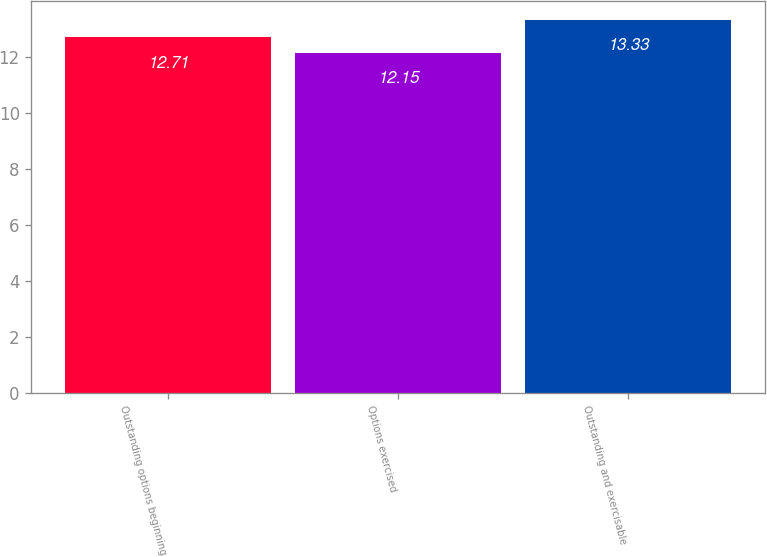Convert chart to OTSL. <chart><loc_0><loc_0><loc_500><loc_500><bar_chart><fcel>Outstanding options beginning<fcel>Options exercised<fcel>Outstanding and exercisable<nl><fcel>12.71<fcel>12.15<fcel>13.33<nl></chart> 